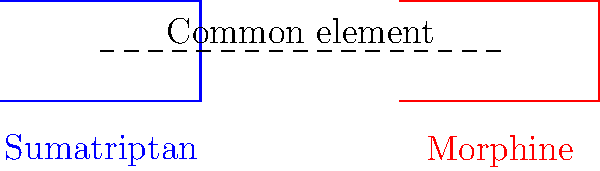Compare the chemical structures of sumatriptan (a common migraine medication) and morphine (an addictive opioid). What structural similarity do you observe, and how might this relate to the potential for addiction in migraine patients? 1. Observe the simplified chemical structures in the diagram:
   - Sumatriptan is represented in blue
   - Morphine is represented in red

2. Note the common structural element (dashed line) between the two molecules:
   - Both structures contain a six-membered ring

3. This structural similarity suggests:
   - Both compounds may interact with similar receptors in the brain
   - The potential for cross-tolerance between migraine medications and opioids

4. Implications for migraine patients with a history of addiction:
   - Increased risk of developing dependence on migraine medications
   - Possible triggering of addictive behaviors
   - Need for careful monitoring and alternative treatment strategies

5. However, it's important to note:
   - Structural similarity doesn't guarantee identical effects
   - Sumatriptan acts primarily on serotonin receptors, while morphine acts on opioid receptors
   - The addiction potential of triptans is generally lower than that of opioids

6. Conclusion:
   - The structural similarity highlights the need for caution in prescribing and using migraine medications, especially for patients with a history of addiction
Answer: Both contain a six-membered ring, potentially increasing addiction risk in susceptible individuals. 